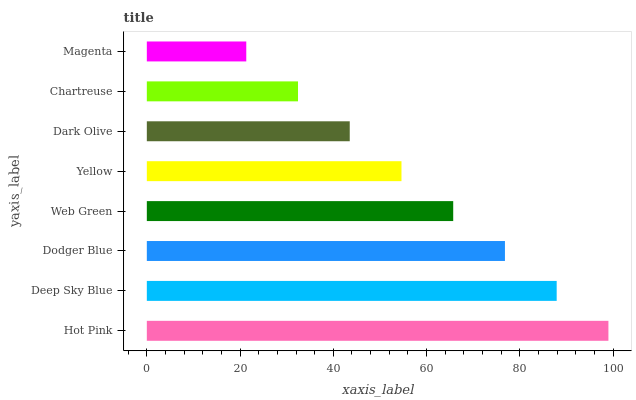Is Magenta the minimum?
Answer yes or no. Yes. Is Hot Pink the maximum?
Answer yes or no. Yes. Is Deep Sky Blue the minimum?
Answer yes or no. No. Is Deep Sky Blue the maximum?
Answer yes or no. No. Is Hot Pink greater than Deep Sky Blue?
Answer yes or no. Yes. Is Deep Sky Blue less than Hot Pink?
Answer yes or no. Yes. Is Deep Sky Blue greater than Hot Pink?
Answer yes or no. No. Is Hot Pink less than Deep Sky Blue?
Answer yes or no. No. Is Web Green the high median?
Answer yes or no. Yes. Is Yellow the low median?
Answer yes or no. Yes. Is Magenta the high median?
Answer yes or no. No. Is Web Green the low median?
Answer yes or no. No. 